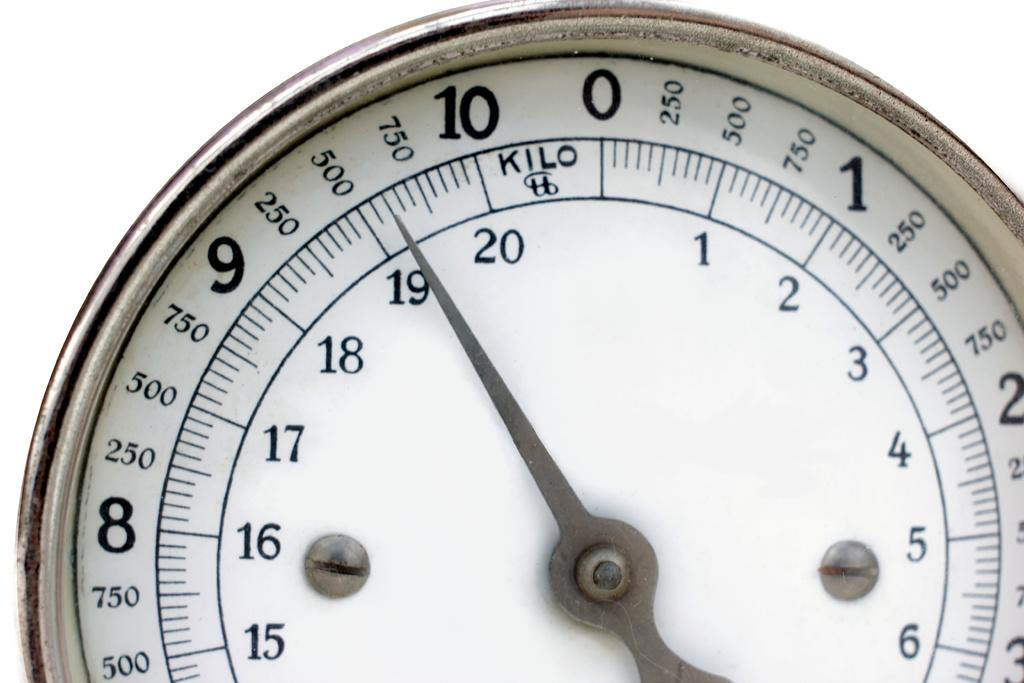Provide a one-sentence caption for the provided image. A watch that measures kilo up to seven hundred and fifty. 